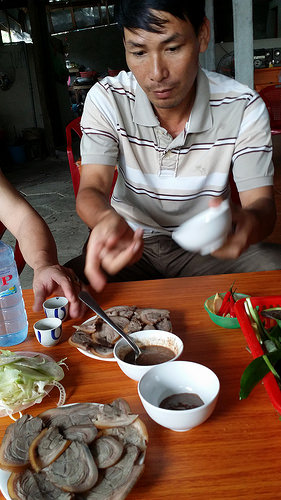<image>
Is there a food in the bowl? No. The food is not contained within the bowl. These objects have a different spatial relationship. Where is the spoon in relation to the food? Is it above the food? Yes. The spoon is positioned above the food in the vertical space, higher up in the scene. 